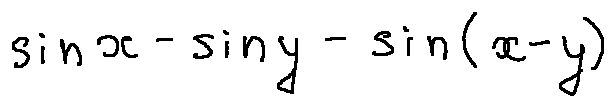Convert formula to latex. <formula><loc_0><loc_0><loc_500><loc_500>\sin x - \sin y - \sin ( x - y )</formula> 